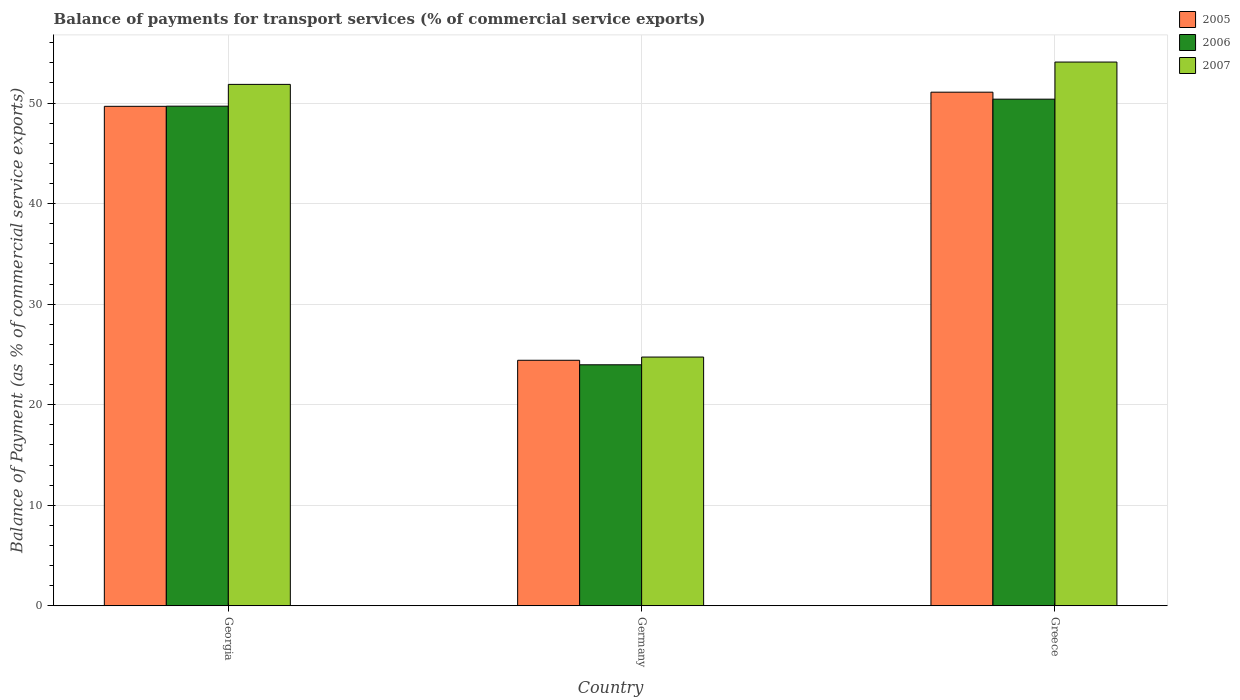How many groups of bars are there?
Your response must be concise. 3. Are the number of bars per tick equal to the number of legend labels?
Offer a terse response. Yes. What is the label of the 3rd group of bars from the left?
Provide a succinct answer. Greece. What is the balance of payments for transport services in 2006 in Greece?
Offer a very short reply. 50.38. Across all countries, what is the maximum balance of payments for transport services in 2006?
Offer a very short reply. 50.38. Across all countries, what is the minimum balance of payments for transport services in 2005?
Ensure brevity in your answer.  24.42. In which country was the balance of payments for transport services in 2006 minimum?
Your answer should be compact. Germany. What is the total balance of payments for transport services in 2007 in the graph?
Your answer should be very brief. 130.66. What is the difference between the balance of payments for transport services in 2007 in Georgia and that in Germany?
Provide a succinct answer. 27.12. What is the difference between the balance of payments for transport services in 2006 in Greece and the balance of payments for transport services in 2007 in Georgia?
Your response must be concise. -1.47. What is the average balance of payments for transport services in 2007 per country?
Your answer should be very brief. 43.55. What is the difference between the balance of payments for transport services of/in 2005 and balance of payments for transport services of/in 2007 in Georgia?
Your answer should be very brief. -2.18. In how many countries, is the balance of payments for transport services in 2007 greater than 8 %?
Your answer should be very brief. 3. What is the ratio of the balance of payments for transport services in 2005 in Georgia to that in Greece?
Provide a short and direct response. 0.97. What is the difference between the highest and the second highest balance of payments for transport services in 2005?
Keep it short and to the point. -25.25. What is the difference between the highest and the lowest balance of payments for transport services in 2006?
Provide a succinct answer. 26.41. In how many countries, is the balance of payments for transport services in 2005 greater than the average balance of payments for transport services in 2005 taken over all countries?
Provide a short and direct response. 2. What does the 2nd bar from the left in Germany represents?
Give a very brief answer. 2006. Is it the case that in every country, the sum of the balance of payments for transport services in 2006 and balance of payments for transport services in 2007 is greater than the balance of payments for transport services in 2005?
Provide a succinct answer. Yes. Are all the bars in the graph horizontal?
Keep it short and to the point. No. How many countries are there in the graph?
Ensure brevity in your answer.  3. Are the values on the major ticks of Y-axis written in scientific E-notation?
Your response must be concise. No. Does the graph contain grids?
Provide a short and direct response. Yes. Where does the legend appear in the graph?
Keep it short and to the point. Top right. How many legend labels are there?
Give a very brief answer. 3. What is the title of the graph?
Your response must be concise. Balance of payments for transport services (% of commercial service exports). What is the label or title of the X-axis?
Your answer should be very brief. Country. What is the label or title of the Y-axis?
Ensure brevity in your answer.  Balance of Payment (as % of commercial service exports). What is the Balance of Payment (as % of commercial service exports) of 2005 in Georgia?
Your response must be concise. 49.67. What is the Balance of Payment (as % of commercial service exports) in 2006 in Georgia?
Your response must be concise. 49.69. What is the Balance of Payment (as % of commercial service exports) in 2007 in Georgia?
Provide a short and direct response. 51.85. What is the Balance of Payment (as % of commercial service exports) in 2005 in Germany?
Ensure brevity in your answer.  24.42. What is the Balance of Payment (as % of commercial service exports) of 2006 in Germany?
Keep it short and to the point. 23.97. What is the Balance of Payment (as % of commercial service exports) of 2007 in Germany?
Offer a terse response. 24.74. What is the Balance of Payment (as % of commercial service exports) in 2005 in Greece?
Offer a very short reply. 51.08. What is the Balance of Payment (as % of commercial service exports) in 2006 in Greece?
Your response must be concise. 50.38. What is the Balance of Payment (as % of commercial service exports) in 2007 in Greece?
Offer a terse response. 54.07. Across all countries, what is the maximum Balance of Payment (as % of commercial service exports) of 2005?
Your answer should be very brief. 51.08. Across all countries, what is the maximum Balance of Payment (as % of commercial service exports) of 2006?
Provide a succinct answer. 50.38. Across all countries, what is the maximum Balance of Payment (as % of commercial service exports) of 2007?
Ensure brevity in your answer.  54.07. Across all countries, what is the minimum Balance of Payment (as % of commercial service exports) of 2005?
Offer a very short reply. 24.42. Across all countries, what is the minimum Balance of Payment (as % of commercial service exports) in 2006?
Offer a very short reply. 23.97. Across all countries, what is the minimum Balance of Payment (as % of commercial service exports) in 2007?
Keep it short and to the point. 24.74. What is the total Balance of Payment (as % of commercial service exports) in 2005 in the graph?
Your response must be concise. 125.16. What is the total Balance of Payment (as % of commercial service exports) in 2006 in the graph?
Your answer should be compact. 124.03. What is the total Balance of Payment (as % of commercial service exports) of 2007 in the graph?
Your answer should be compact. 130.66. What is the difference between the Balance of Payment (as % of commercial service exports) in 2005 in Georgia and that in Germany?
Provide a succinct answer. 25.25. What is the difference between the Balance of Payment (as % of commercial service exports) of 2006 in Georgia and that in Germany?
Keep it short and to the point. 25.72. What is the difference between the Balance of Payment (as % of commercial service exports) in 2007 in Georgia and that in Germany?
Your answer should be very brief. 27.12. What is the difference between the Balance of Payment (as % of commercial service exports) of 2005 in Georgia and that in Greece?
Give a very brief answer. -1.41. What is the difference between the Balance of Payment (as % of commercial service exports) in 2006 in Georgia and that in Greece?
Provide a succinct answer. -0.7. What is the difference between the Balance of Payment (as % of commercial service exports) of 2007 in Georgia and that in Greece?
Your answer should be very brief. -2.22. What is the difference between the Balance of Payment (as % of commercial service exports) in 2005 in Germany and that in Greece?
Provide a short and direct response. -26.66. What is the difference between the Balance of Payment (as % of commercial service exports) in 2006 in Germany and that in Greece?
Offer a very short reply. -26.41. What is the difference between the Balance of Payment (as % of commercial service exports) of 2007 in Germany and that in Greece?
Provide a short and direct response. -29.34. What is the difference between the Balance of Payment (as % of commercial service exports) in 2005 in Georgia and the Balance of Payment (as % of commercial service exports) in 2006 in Germany?
Your response must be concise. 25.7. What is the difference between the Balance of Payment (as % of commercial service exports) in 2005 in Georgia and the Balance of Payment (as % of commercial service exports) in 2007 in Germany?
Give a very brief answer. 24.93. What is the difference between the Balance of Payment (as % of commercial service exports) of 2006 in Georgia and the Balance of Payment (as % of commercial service exports) of 2007 in Germany?
Provide a succinct answer. 24.95. What is the difference between the Balance of Payment (as % of commercial service exports) in 2005 in Georgia and the Balance of Payment (as % of commercial service exports) in 2006 in Greece?
Your answer should be compact. -0.71. What is the difference between the Balance of Payment (as % of commercial service exports) in 2005 in Georgia and the Balance of Payment (as % of commercial service exports) in 2007 in Greece?
Offer a very short reply. -4.4. What is the difference between the Balance of Payment (as % of commercial service exports) of 2006 in Georgia and the Balance of Payment (as % of commercial service exports) of 2007 in Greece?
Give a very brief answer. -4.39. What is the difference between the Balance of Payment (as % of commercial service exports) in 2005 in Germany and the Balance of Payment (as % of commercial service exports) in 2006 in Greece?
Your response must be concise. -25.97. What is the difference between the Balance of Payment (as % of commercial service exports) in 2005 in Germany and the Balance of Payment (as % of commercial service exports) in 2007 in Greece?
Make the answer very short. -29.66. What is the difference between the Balance of Payment (as % of commercial service exports) in 2006 in Germany and the Balance of Payment (as % of commercial service exports) in 2007 in Greece?
Your answer should be compact. -30.11. What is the average Balance of Payment (as % of commercial service exports) of 2005 per country?
Your answer should be compact. 41.72. What is the average Balance of Payment (as % of commercial service exports) of 2006 per country?
Your answer should be very brief. 41.34. What is the average Balance of Payment (as % of commercial service exports) of 2007 per country?
Provide a succinct answer. 43.55. What is the difference between the Balance of Payment (as % of commercial service exports) in 2005 and Balance of Payment (as % of commercial service exports) in 2006 in Georgia?
Your response must be concise. -0.02. What is the difference between the Balance of Payment (as % of commercial service exports) in 2005 and Balance of Payment (as % of commercial service exports) in 2007 in Georgia?
Offer a terse response. -2.18. What is the difference between the Balance of Payment (as % of commercial service exports) in 2006 and Balance of Payment (as % of commercial service exports) in 2007 in Georgia?
Ensure brevity in your answer.  -2.17. What is the difference between the Balance of Payment (as % of commercial service exports) in 2005 and Balance of Payment (as % of commercial service exports) in 2006 in Germany?
Your response must be concise. 0.45. What is the difference between the Balance of Payment (as % of commercial service exports) of 2005 and Balance of Payment (as % of commercial service exports) of 2007 in Germany?
Offer a very short reply. -0.32. What is the difference between the Balance of Payment (as % of commercial service exports) in 2006 and Balance of Payment (as % of commercial service exports) in 2007 in Germany?
Give a very brief answer. -0.77. What is the difference between the Balance of Payment (as % of commercial service exports) of 2005 and Balance of Payment (as % of commercial service exports) of 2006 in Greece?
Ensure brevity in your answer.  0.7. What is the difference between the Balance of Payment (as % of commercial service exports) in 2005 and Balance of Payment (as % of commercial service exports) in 2007 in Greece?
Your answer should be very brief. -2.99. What is the difference between the Balance of Payment (as % of commercial service exports) in 2006 and Balance of Payment (as % of commercial service exports) in 2007 in Greece?
Offer a very short reply. -3.69. What is the ratio of the Balance of Payment (as % of commercial service exports) in 2005 in Georgia to that in Germany?
Your answer should be compact. 2.03. What is the ratio of the Balance of Payment (as % of commercial service exports) of 2006 in Georgia to that in Germany?
Offer a very short reply. 2.07. What is the ratio of the Balance of Payment (as % of commercial service exports) in 2007 in Georgia to that in Germany?
Ensure brevity in your answer.  2.1. What is the ratio of the Balance of Payment (as % of commercial service exports) of 2005 in Georgia to that in Greece?
Your response must be concise. 0.97. What is the ratio of the Balance of Payment (as % of commercial service exports) of 2006 in Georgia to that in Greece?
Offer a terse response. 0.99. What is the ratio of the Balance of Payment (as % of commercial service exports) of 2007 in Georgia to that in Greece?
Your answer should be compact. 0.96. What is the ratio of the Balance of Payment (as % of commercial service exports) of 2005 in Germany to that in Greece?
Your answer should be compact. 0.48. What is the ratio of the Balance of Payment (as % of commercial service exports) in 2006 in Germany to that in Greece?
Ensure brevity in your answer.  0.48. What is the ratio of the Balance of Payment (as % of commercial service exports) of 2007 in Germany to that in Greece?
Give a very brief answer. 0.46. What is the difference between the highest and the second highest Balance of Payment (as % of commercial service exports) in 2005?
Keep it short and to the point. 1.41. What is the difference between the highest and the second highest Balance of Payment (as % of commercial service exports) in 2006?
Your response must be concise. 0.7. What is the difference between the highest and the second highest Balance of Payment (as % of commercial service exports) of 2007?
Provide a succinct answer. 2.22. What is the difference between the highest and the lowest Balance of Payment (as % of commercial service exports) of 2005?
Provide a succinct answer. 26.66. What is the difference between the highest and the lowest Balance of Payment (as % of commercial service exports) in 2006?
Your response must be concise. 26.41. What is the difference between the highest and the lowest Balance of Payment (as % of commercial service exports) in 2007?
Keep it short and to the point. 29.34. 